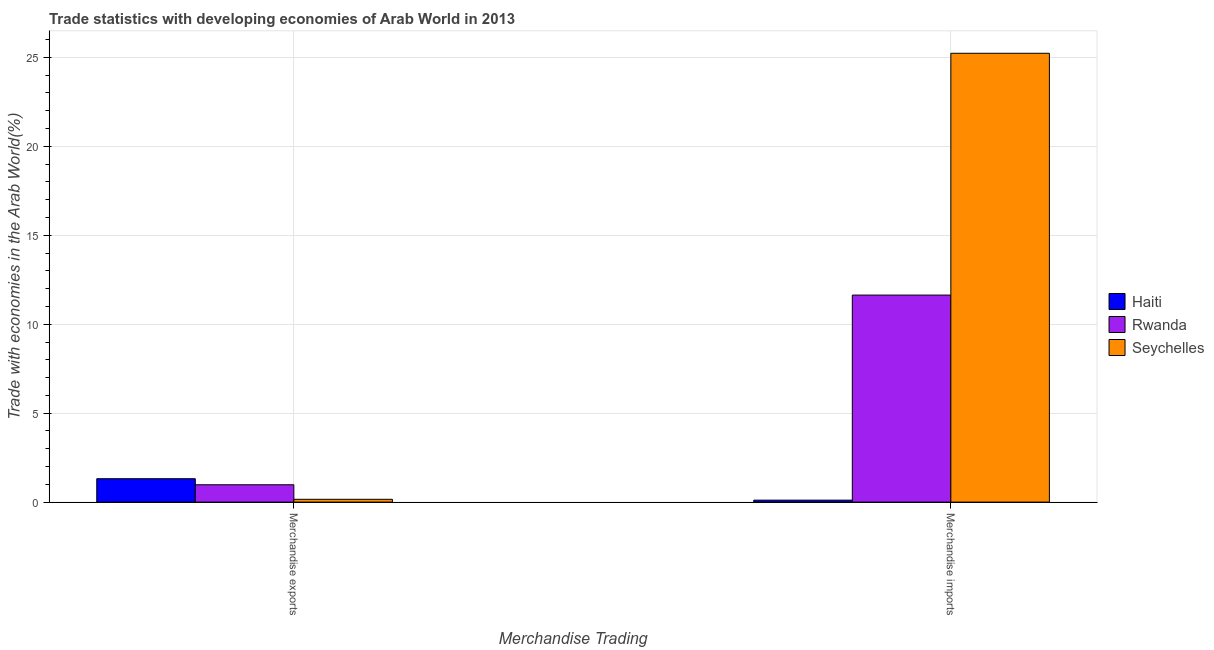How many different coloured bars are there?
Your response must be concise. 3. How many bars are there on the 1st tick from the left?
Offer a terse response. 3. How many bars are there on the 2nd tick from the right?
Provide a succinct answer. 3. What is the merchandise imports in Seychelles?
Keep it short and to the point. 25.23. Across all countries, what is the maximum merchandise imports?
Your answer should be very brief. 25.23. Across all countries, what is the minimum merchandise exports?
Make the answer very short. 0.16. In which country was the merchandise imports maximum?
Ensure brevity in your answer.  Seychelles. In which country was the merchandise imports minimum?
Offer a very short reply. Haiti. What is the total merchandise imports in the graph?
Give a very brief answer. 36.98. What is the difference between the merchandise imports in Rwanda and that in Seychelles?
Give a very brief answer. -13.59. What is the difference between the merchandise exports in Haiti and the merchandise imports in Rwanda?
Keep it short and to the point. -10.32. What is the average merchandise exports per country?
Provide a succinct answer. 0.82. What is the difference between the merchandise imports and merchandise exports in Rwanda?
Keep it short and to the point. 10.66. What is the ratio of the merchandise exports in Haiti to that in Rwanda?
Your answer should be compact. 1.35. In how many countries, is the merchandise exports greater than the average merchandise exports taken over all countries?
Your answer should be very brief. 2. What does the 3rd bar from the left in Merchandise exports represents?
Provide a succinct answer. Seychelles. What does the 3rd bar from the right in Merchandise exports represents?
Offer a terse response. Haiti. How many countries are there in the graph?
Make the answer very short. 3. What is the difference between two consecutive major ticks on the Y-axis?
Your response must be concise. 5. Are the values on the major ticks of Y-axis written in scientific E-notation?
Ensure brevity in your answer.  No. Does the graph contain grids?
Give a very brief answer. Yes. What is the title of the graph?
Make the answer very short. Trade statistics with developing economies of Arab World in 2013. Does "Brazil" appear as one of the legend labels in the graph?
Your response must be concise. No. What is the label or title of the X-axis?
Give a very brief answer. Merchandise Trading. What is the label or title of the Y-axis?
Your response must be concise. Trade with economies in the Arab World(%). What is the Trade with economies in the Arab World(%) of Haiti in Merchandise exports?
Your response must be concise. 1.32. What is the Trade with economies in the Arab World(%) in Rwanda in Merchandise exports?
Ensure brevity in your answer.  0.98. What is the Trade with economies in the Arab World(%) of Seychelles in Merchandise exports?
Your response must be concise. 0.16. What is the Trade with economies in the Arab World(%) of Haiti in Merchandise imports?
Your answer should be very brief. 0.11. What is the Trade with economies in the Arab World(%) of Rwanda in Merchandise imports?
Provide a short and direct response. 11.64. What is the Trade with economies in the Arab World(%) of Seychelles in Merchandise imports?
Offer a very short reply. 25.23. Across all Merchandise Trading, what is the maximum Trade with economies in the Arab World(%) of Haiti?
Provide a short and direct response. 1.32. Across all Merchandise Trading, what is the maximum Trade with economies in the Arab World(%) of Rwanda?
Your response must be concise. 11.64. Across all Merchandise Trading, what is the maximum Trade with economies in the Arab World(%) of Seychelles?
Ensure brevity in your answer.  25.23. Across all Merchandise Trading, what is the minimum Trade with economies in the Arab World(%) in Haiti?
Your answer should be very brief. 0.11. Across all Merchandise Trading, what is the minimum Trade with economies in the Arab World(%) in Rwanda?
Provide a short and direct response. 0.98. Across all Merchandise Trading, what is the minimum Trade with economies in the Arab World(%) of Seychelles?
Make the answer very short. 0.16. What is the total Trade with economies in the Arab World(%) in Haiti in the graph?
Make the answer very short. 1.43. What is the total Trade with economies in the Arab World(%) in Rwanda in the graph?
Your answer should be very brief. 12.61. What is the total Trade with economies in the Arab World(%) in Seychelles in the graph?
Keep it short and to the point. 25.39. What is the difference between the Trade with economies in the Arab World(%) in Haiti in Merchandise exports and that in Merchandise imports?
Keep it short and to the point. 1.21. What is the difference between the Trade with economies in the Arab World(%) in Rwanda in Merchandise exports and that in Merchandise imports?
Keep it short and to the point. -10.66. What is the difference between the Trade with economies in the Arab World(%) in Seychelles in Merchandise exports and that in Merchandise imports?
Provide a succinct answer. -25.07. What is the difference between the Trade with economies in the Arab World(%) in Haiti in Merchandise exports and the Trade with economies in the Arab World(%) in Rwanda in Merchandise imports?
Provide a short and direct response. -10.32. What is the difference between the Trade with economies in the Arab World(%) of Haiti in Merchandise exports and the Trade with economies in the Arab World(%) of Seychelles in Merchandise imports?
Offer a very short reply. -23.91. What is the difference between the Trade with economies in the Arab World(%) of Rwanda in Merchandise exports and the Trade with economies in the Arab World(%) of Seychelles in Merchandise imports?
Offer a terse response. -24.25. What is the average Trade with economies in the Arab World(%) in Haiti per Merchandise Trading?
Your answer should be compact. 0.71. What is the average Trade with economies in the Arab World(%) in Rwanda per Merchandise Trading?
Keep it short and to the point. 6.31. What is the average Trade with economies in the Arab World(%) in Seychelles per Merchandise Trading?
Provide a succinct answer. 12.69. What is the difference between the Trade with economies in the Arab World(%) in Haiti and Trade with economies in the Arab World(%) in Rwanda in Merchandise exports?
Keep it short and to the point. 0.34. What is the difference between the Trade with economies in the Arab World(%) in Haiti and Trade with economies in the Arab World(%) in Seychelles in Merchandise exports?
Make the answer very short. 1.16. What is the difference between the Trade with economies in the Arab World(%) in Rwanda and Trade with economies in the Arab World(%) in Seychelles in Merchandise exports?
Offer a very short reply. 0.82. What is the difference between the Trade with economies in the Arab World(%) in Haiti and Trade with economies in the Arab World(%) in Rwanda in Merchandise imports?
Your response must be concise. -11.53. What is the difference between the Trade with economies in the Arab World(%) in Haiti and Trade with economies in the Arab World(%) in Seychelles in Merchandise imports?
Your answer should be very brief. -25.12. What is the difference between the Trade with economies in the Arab World(%) in Rwanda and Trade with economies in the Arab World(%) in Seychelles in Merchandise imports?
Provide a short and direct response. -13.59. What is the ratio of the Trade with economies in the Arab World(%) in Haiti in Merchandise exports to that in Merchandise imports?
Keep it short and to the point. 11.84. What is the ratio of the Trade with economies in the Arab World(%) of Rwanda in Merchandise exports to that in Merchandise imports?
Your answer should be very brief. 0.08. What is the ratio of the Trade with economies in the Arab World(%) of Seychelles in Merchandise exports to that in Merchandise imports?
Your answer should be compact. 0.01. What is the difference between the highest and the second highest Trade with economies in the Arab World(%) in Haiti?
Offer a terse response. 1.21. What is the difference between the highest and the second highest Trade with economies in the Arab World(%) in Rwanda?
Your response must be concise. 10.66. What is the difference between the highest and the second highest Trade with economies in the Arab World(%) of Seychelles?
Your answer should be very brief. 25.07. What is the difference between the highest and the lowest Trade with economies in the Arab World(%) in Haiti?
Your answer should be very brief. 1.21. What is the difference between the highest and the lowest Trade with economies in the Arab World(%) in Rwanda?
Give a very brief answer. 10.66. What is the difference between the highest and the lowest Trade with economies in the Arab World(%) in Seychelles?
Offer a very short reply. 25.07. 